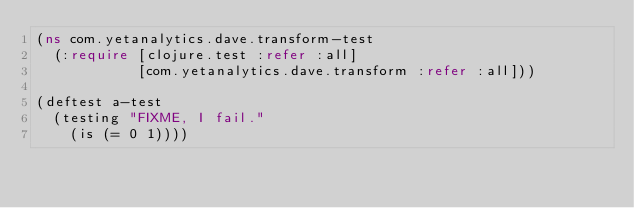<code> <loc_0><loc_0><loc_500><loc_500><_Clojure_>(ns com.yetanalytics.dave.transform-test
  (:require [clojure.test :refer :all]
            [com.yetanalytics.dave.transform :refer :all]))

(deftest a-test
  (testing "FIXME, I fail."
    (is (= 0 1))))
</code> 